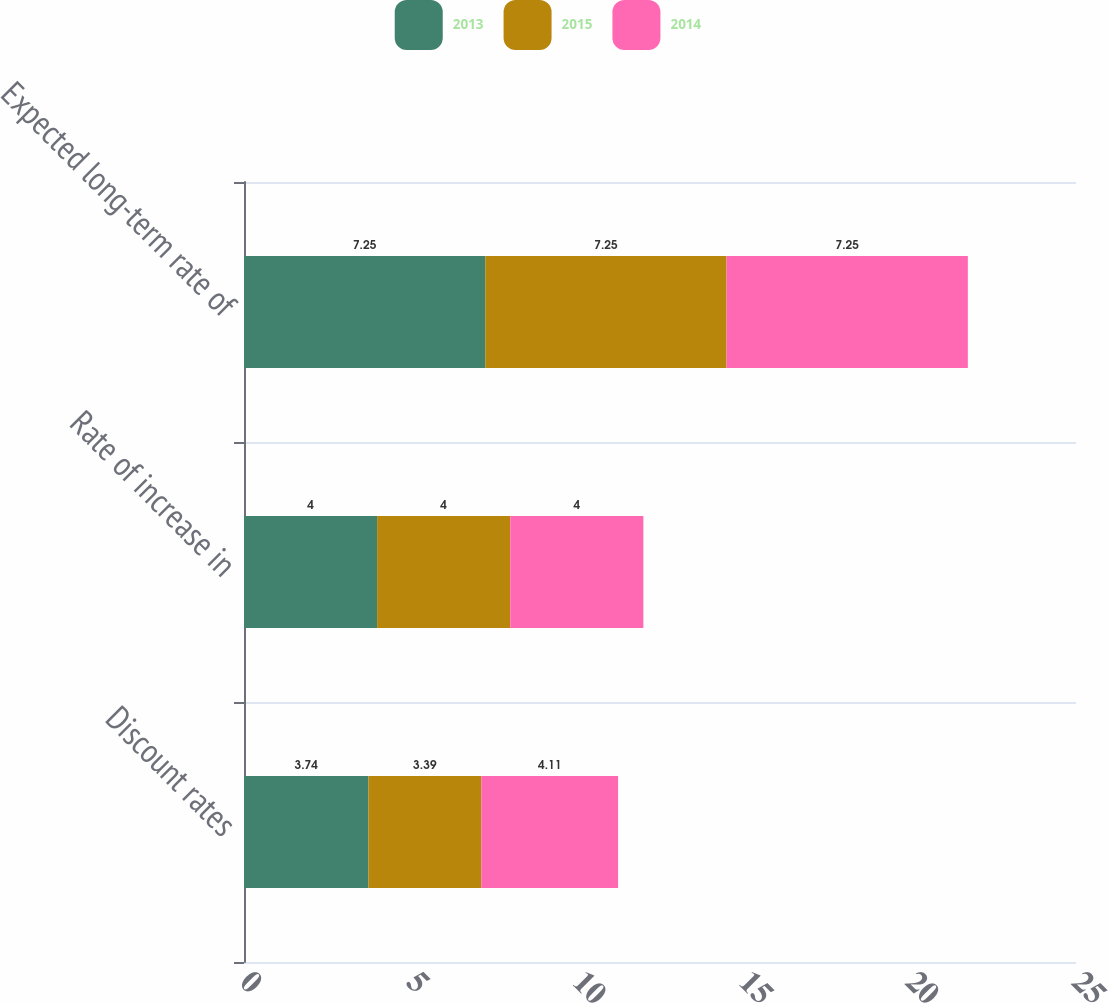Convert chart to OTSL. <chart><loc_0><loc_0><loc_500><loc_500><stacked_bar_chart><ecel><fcel>Discount rates<fcel>Rate of increase in<fcel>Expected long-term rate of<nl><fcel>2013<fcel>3.74<fcel>4<fcel>7.25<nl><fcel>2015<fcel>3.39<fcel>4<fcel>7.25<nl><fcel>2014<fcel>4.11<fcel>4<fcel>7.25<nl></chart> 